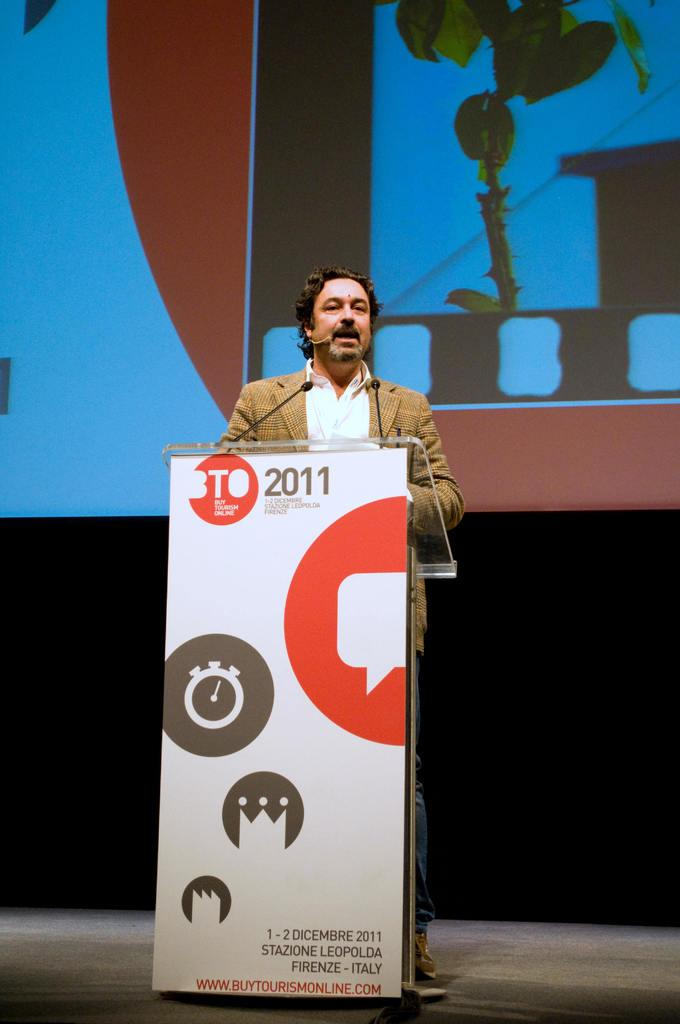Provide a one-sentence caption for the provided image. A person at a podium that has a banner which read BTO 2011. 